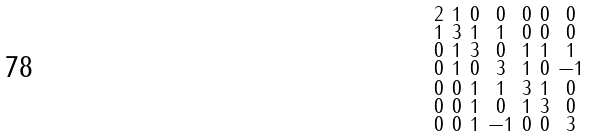Convert formula to latex. <formula><loc_0><loc_0><loc_500><loc_500>\begin{smallmatrix} 2 & 1 & 0 & 0 & 0 & 0 & 0 \\ 1 & 3 & 1 & 1 & 0 & 0 & 0 \\ 0 & 1 & 3 & 0 & 1 & 1 & 1 \\ 0 & 1 & 0 & 3 & 1 & 0 & - 1 \\ 0 & 0 & 1 & 1 & 3 & 1 & 0 \\ 0 & 0 & 1 & 0 & 1 & 3 & 0 \\ 0 & 0 & 1 & - 1 & 0 & 0 & 3 \end{smallmatrix}</formula> 